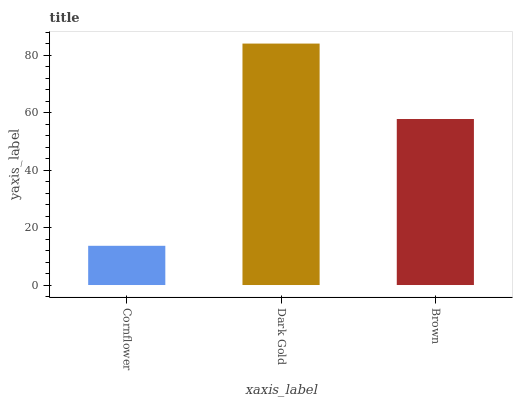Is Brown the minimum?
Answer yes or no. No. Is Brown the maximum?
Answer yes or no. No. Is Dark Gold greater than Brown?
Answer yes or no. Yes. Is Brown less than Dark Gold?
Answer yes or no. Yes. Is Brown greater than Dark Gold?
Answer yes or no. No. Is Dark Gold less than Brown?
Answer yes or no. No. Is Brown the high median?
Answer yes or no. Yes. Is Brown the low median?
Answer yes or no. Yes. Is Dark Gold the high median?
Answer yes or no. No. Is Cornflower the low median?
Answer yes or no. No. 